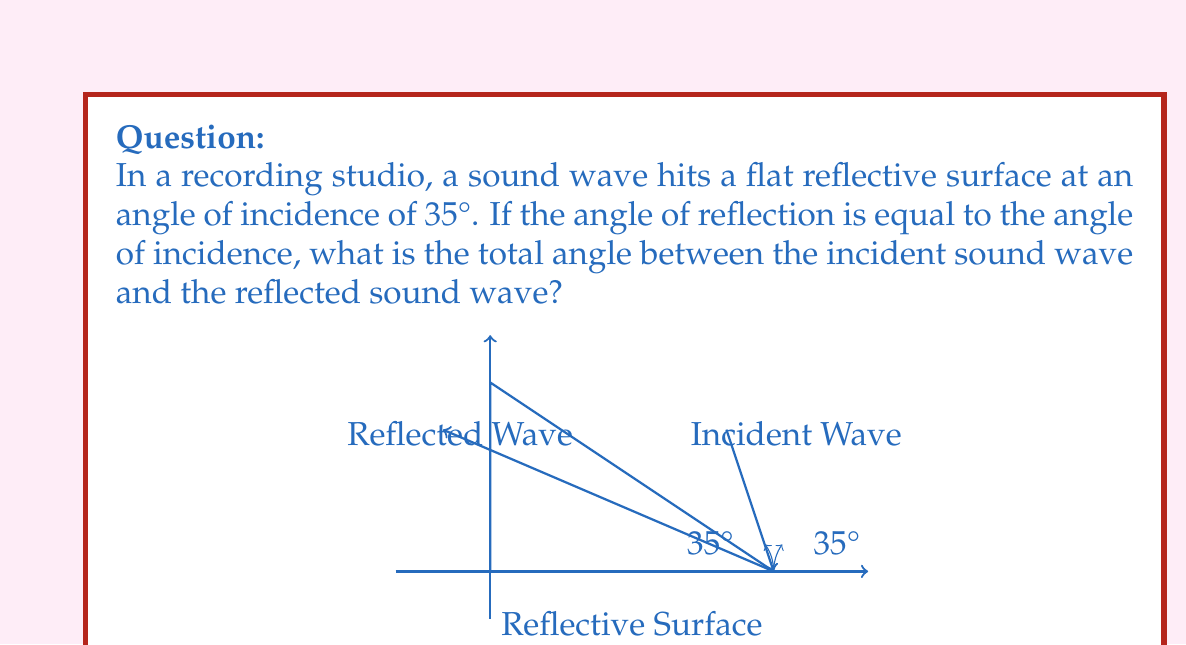Show me your answer to this math problem. Let's approach this step-by-step:

1) First, recall the law of reflection: The angle of incidence is equal to the angle of reflection. In this case, both angles are 35°.

2) We need to find the total angle between the incident wave and the reflected wave. This can be visualized as the angle formed by the two waves if we extend them to meet at a point.

3) To calculate this, we can use the fact that the sum of angles in a triangle is always 180°.

4) Let's consider the triangle formed by:
   - The incident wave
   - The reflected wave
   - The reflective surface

5) We know two angles in this triangle:
   - The angle between the incident wave and the surface: 35°
   - The angle between the reflected wave and the surface: 35°

6) Let $x$ be the angle we're looking for. We can set up an equation:

   $$ 35° + 35° + x = 180° $$

7) Simplifying:

   $$ 70° + x = 180° $$

8) Solving for $x$:

   $$ x = 180° - 70° = 110° $$

Therefore, the total angle between the incident sound wave and the reflected sound wave is 110°.
Answer: 110° 